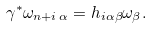<formula> <loc_0><loc_0><loc_500><loc_500>\gamma ^ { \ast } \omega _ { n + i \, \alpha } = h _ { i \alpha \beta } \omega _ { \beta } .</formula> 